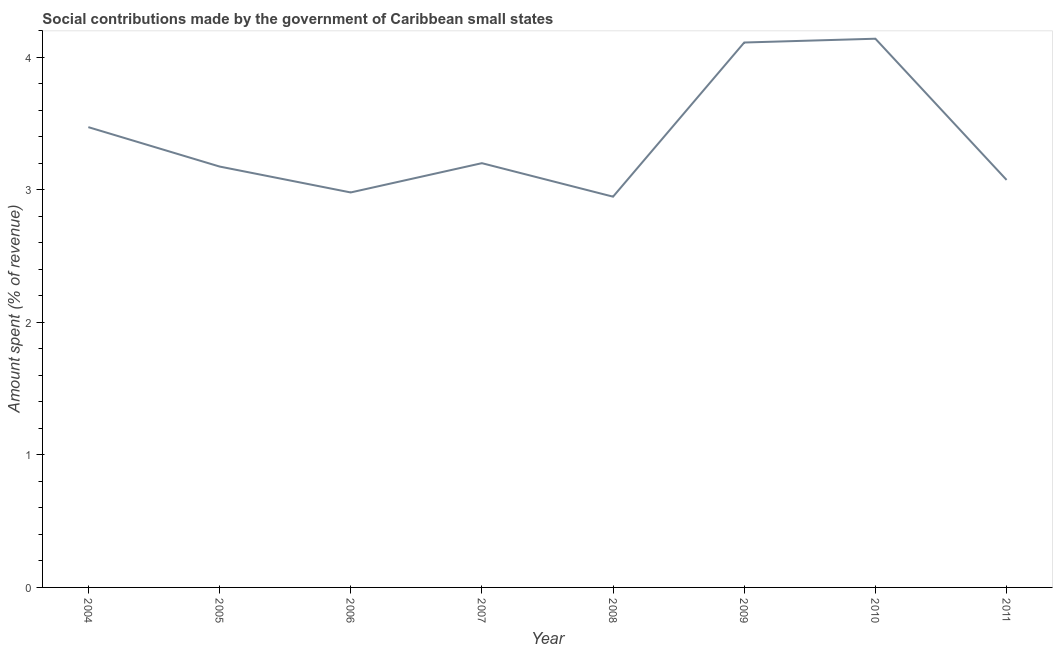What is the amount spent in making social contributions in 2007?
Your response must be concise. 3.2. Across all years, what is the maximum amount spent in making social contributions?
Your response must be concise. 4.14. Across all years, what is the minimum amount spent in making social contributions?
Offer a terse response. 2.95. In which year was the amount spent in making social contributions maximum?
Offer a very short reply. 2010. In which year was the amount spent in making social contributions minimum?
Your answer should be compact. 2008. What is the sum of the amount spent in making social contributions?
Your response must be concise. 27.11. What is the difference between the amount spent in making social contributions in 2007 and 2009?
Provide a succinct answer. -0.91. What is the average amount spent in making social contributions per year?
Keep it short and to the point. 3.39. What is the median amount spent in making social contributions?
Your answer should be very brief. 3.19. What is the ratio of the amount spent in making social contributions in 2005 to that in 2009?
Provide a short and direct response. 0.77. Is the difference between the amount spent in making social contributions in 2005 and 2007 greater than the difference between any two years?
Make the answer very short. No. What is the difference between the highest and the second highest amount spent in making social contributions?
Offer a terse response. 0.03. What is the difference between the highest and the lowest amount spent in making social contributions?
Give a very brief answer. 1.19. Does the amount spent in making social contributions monotonically increase over the years?
Offer a terse response. No. How many lines are there?
Keep it short and to the point. 1. Are the values on the major ticks of Y-axis written in scientific E-notation?
Your answer should be very brief. No. Does the graph contain any zero values?
Ensure brevity in your answer.  No. Does the graph contain grids?
Provide a short and direct response. No. What is the title of the graph?
Provide a short and direct response. Social contributions made by the government of Caribbean small states. What is the label or title of the X-axis?
Your response must be concise. Year. What is the label or title of the Y-axis?
Ensure brevity in your answer.  Amount spent (% of revenue). What is the Amount spent (% of revenue) of 2004?
Your response must be concise. 3.47. What is the Amount spent (% of revenue) of 2005?
Provide a succinct answer. 3.18. What is the Amount spent (% of revenue) of 2006?
Offer a very short reply. 2.98. What is the Amount spent (% of revenue) in 2007?
Provide a succinct answer. 3.2. What is the Amount spent (% of revenue) in 2008?
Offer a terse response. 2.95. What is the Amount spent (% of revenue) in 2009?
Your response must be concise. 4.11. What is the Amount spent (% of revenue) in 2010?
Provide a short and direct response. 4.14. What is the Amount spent (% of revenue) of 2011?
Your answer should be very brief. 3.08. What is the difference between the Amount spent (% of revenue) in 2004 and 2005?
Provide a succinct answer. 0.3. What is the difference between the Amount spent (% of revenue) in 2004 and 2006?
Give a very brief answer. 0.49. What is the difference between the Amount spent (% of revenue) in 2004 and 2007?
Your answer should be very brief. 0.27. What is the difference between the Amount spent (% of revenue) in 2004 and 2008?
Make the answer very short. 0.52. What is the difference between the Amount spent (% of revenue) in 2004 and 2009?
Your answer should be very brief. -0.64. What is the difference between the Amount spent (% of revenue) in 2004 and 2010?
Your response must be concise. -0.67. What is the difference between the Amount spent (% of revenue) in 2004 and 2011?
Make the answer very short. 0.4. What is the difference between the Amount spent (% of revenue) in 2005 and 2006?
Offer a terse response. 0.2. What is the difference between the Amount spent (% of revenue) in 2005 and 2007?
Give a very brief answer. -0.03. What is the difference between the Amount spent (% of revenue) in 2005 and 2008?
Your answer should be compact. 0.23. What is the difference between the Amount spent (% of revenue) in 2005 and 2009?
Your answer should be compact. -0.94. What is the difference between the Amount spent (% of revenue) in 2005 and 2010?
Offer a very short reply. -0.96. What is the difference between the Amount spent (% of revenue) in 2005 and 2011?
Ensure brevity in your answer.  0.1. What is the difference between the Amount spent (% of revenue) in 2006 and 2007?
Provide a short and direct response. -0.22. What is the difference between the Amount spent (% of revenue) in 2006 and 2008?
Your answer should be compact. 0.03. What is the difference between the Amount spent (% of revenue) in 2006 and 2009?
Give a very brief answer. -1.13. What is the difference between the Amount spent (% of revenue) in 2006 and 2010?
Give a very brief answer. -1.16. What is the difference between the Amount spent (% of revenue) in 2006 and 2011?
Give a very brief answer. -0.09. What is the difference between the Amount spent (% of revenue) in 2007 and 2008?
Your answer should be compact. 0.25. What is the difference between the Amount spent (% of revenue) in 2007 and 2009?
Your response must be concise. -0.91. What is the difference between the Amount spent (% of revenue) in 2007 and 2010?
Ensure brevity in your answer.  -0.94. What is the difference between the Amount spent (% of revenue) in 2007 and 2011?
Offer a very short reply. 0.13. What is the difference between the Amount spent (% of revenue) in 2008 and 2009?
Ensure brevity in your answer.  -1.16. What is the difference between the Amount spent (% of revenue) in 2008 and 2010?
Your answer should be very brief. -1.19. What is the difference between the Amount spent (% of revenue) in 2008 and 2011?
Make the answer very short. -0.13. What is the difference between the Amount spent (% of revenue) in 2009 and 2010?
Give a very brief answer. -0.03. What is the difference between the Amount spent (% of revenue) in 2009 and 2011?
Offer a terse response. 1.04. What is the difference between the Amount spent (% of revenue) in 2010 and 2011?
Give a very brief answer. 1.07. What is the ratio of the Amount spent (% of revenue) in 2004 to that in 2005?
Your answer should be compact. 1.09. What is the ratio of the Amount spent (% of revenue) in 2004 to that in 2006?
Keep it short and to the point. 1.17. What is the ratio of the Amount spent (% of revenue) in 2004 to that in 2007?
Keep it short and to the point. 1.08. What is the ratio of the Amount spent (% of revenue) in 2004 to that in 2008?
Give a very brief answer. 1.18. What is the ratio of the Amount spent (% of revenue) in 2004 to that in 2009?
Provide a succinct answer. 0.84. What is the ratio of the Amount spent (% of revenue) in 2004 to that in 2010?
Your response must be concise. 0.84. What is the ratio of the Amount spent (% of revenue) in 2004 to that in 2011?
Offer a terse response. 1.13. What is the ratio of the Amount spent (% of revenue) in 2005 to that in 2006?
Offer a terse response. 1.07. What is the ratio of the Amount spent (% of revenue) in 2005 to that in 2008?
Keep it short and to the point. 1.08. What is the ratio of the Amount spent (% of revenue) in 2005 to that in 2009?
Provide a succinct answer. 0.77. What is the ratio of the Amount spent (% of revenue) in 2005 to that in 2010?
Provide a short and direct response. 0.77. What is the ratio of the Amount spent (% of revenue) in 2005 to that in 2011?
Keep it short and to the point. 1.03. What is the ratio of the Amount spent (% of revenue) in 2006 to that in 2007?
Your answer should be compact. 0.93. What is the ratio of the Amount spent (% of revenue) in 2006 to that in 2008?
Make the answer very short. 1.01. What is the ratio of the Amount spent (% of revenue) in 2006 to that in 2009?
Your response must be concise. 0.72. What is the ratio of the Amount spent (% of revenue) in 2006 to that in 2010?
Your answer should be compact. 0.72. What is the ratio of the Amount spent (% of revenue) in 2007 to that in 2008?
Your response must be concise. 1.09. What is the ratio of the Amount spent (% of revenue) in 2007 to that in 2009?
Your response must be concise. 0.78. What is the ratio of the Amount spent (% of revenue) in 2007 to that in 2010?
Your response must be concise. 0.77. What is the ratio of the Amount spent (% of revenue) in 2007 to that in 2011?
Your answer should be very brief. 1.04. What is the ratio of the Amount spent (% of revenue) in 2008 to that in 2009?
Keep it short and to the point. 0.72. What is the ratio of the Amount spent (% of revenue) in 2008 to that in 2010?
Provide a succinct answer. 0.71. What is the ratio of the Amount spent (% of revenue) in 2009 to that in 2011?
Provide a succinct answer. 1.34. What is the ratio of the Amount spent (% of revenue) in 2010 to that in 2011?
Your response must be concise. 1.35. 